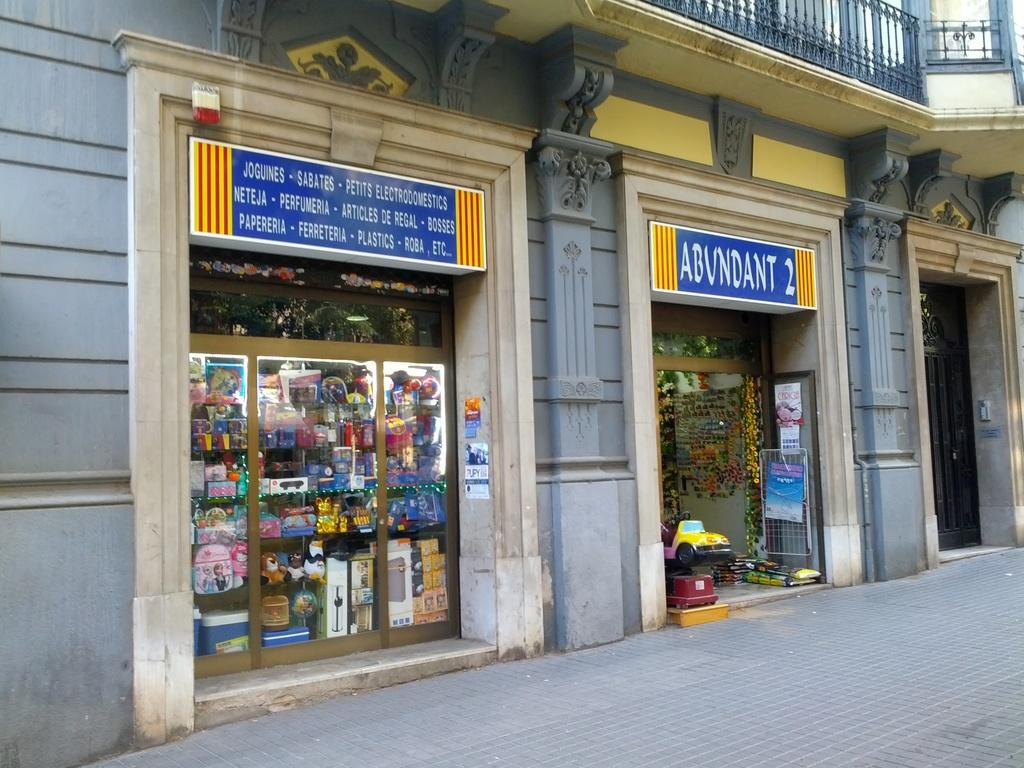<image>
Create a compact narrative representing the image presented. Outside of a foreign store that sells joguines, sabates, plastics-roba and other items. 